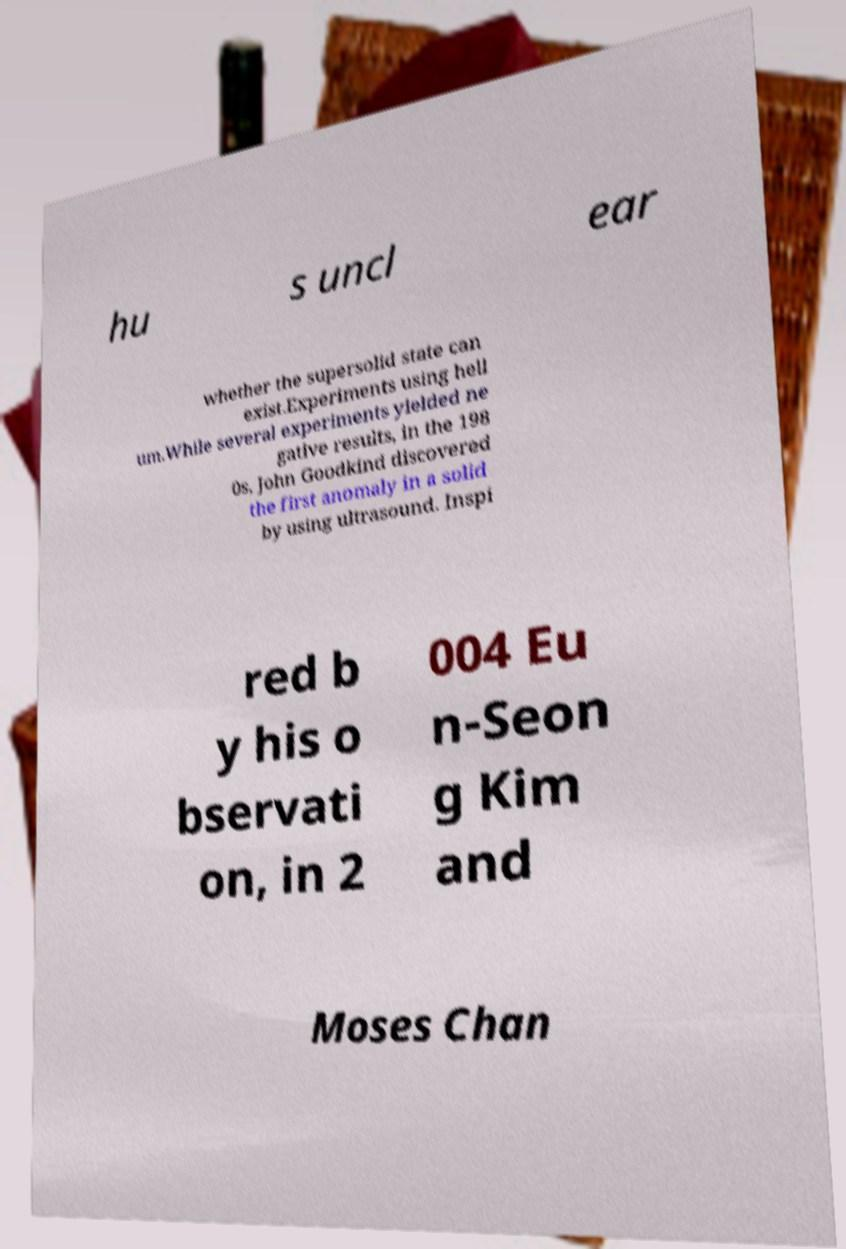For documentation purposes, I need the text within this image transcribed. Could you provide that? hu s uncl ear whether the supersolid state can exist.Experiments using heli um.While several experiments yielded ne gative results, in the 198 0s, John Goodkind discovered the first anomaly in a solid by using ultrasound. Inspi red b y his o bservati on, in 2 004 Eu n-Seon g Kim and Moses Chan 